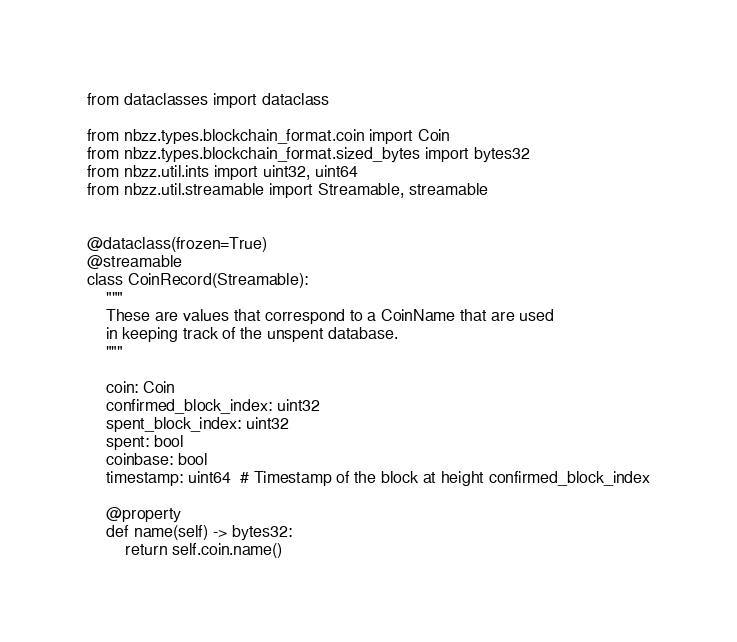<code> <loc_0><loc_0><loc_500><loc_500><_Python_>from dataclasses import dataclass

from nbzz.types.blockchain_format.coin import Coin
from nbzz.types.blockchain_format.sized_bytes import bytes32
from nbzz.util.ints import uint32, uint64
from nbzz.util.streamable import Streamable, streamable


@dataclass(frozen=True)
@streamable
class CoinRecord(Streamable):
    """
    These are values that correspond to a CoinName that are used
    in keeping track of the unspent database.
    """

    coin: Coin
    confirmed_block_index: uint32
    spent_block_index: uint32
    spent: bool
    coinbase: bool
    timestamp: uint64  # Timestamp of the block at height confirmed_block_index

    @property
    def name(self) -> bytes32:
        return self.coin.name()
</code> 